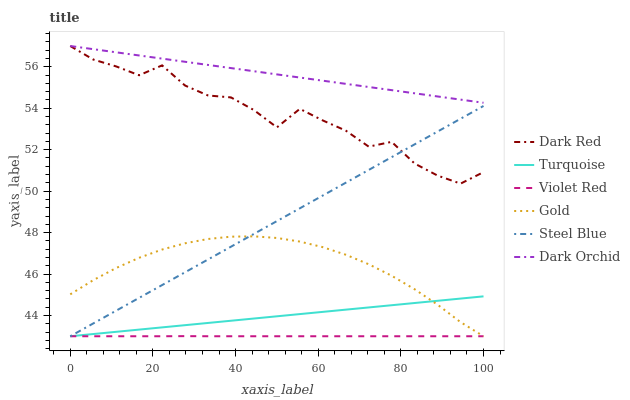Does Violet Red have the minimum area under the curve?
Answer yes or no. Yes. Does Dark Orchid have the maximum area under the curve?
Answer yes or no. Yes. Does Gold have the minimum area under the curve?
Answer yes or no. No. Does Gold have the maximum area under the curve?
Answer yes or no. No. Is Dark Orchid the smoothest?
Answer yes or no. Yes. Is Dark Red the roughest?
Answer yes or no. Yes. Is Gold the smoothest?
Answer yes or no. No. Is Gold the roughest?
Answer yes or no. No. Does Turquoise have the lowest value?
Answer yes or no. Yes. Does Dark Red have the lowest value?
Answer yes or no. No. Does Dark Orchid have the highest value?
Answer yes or no. Yes. Does Gold have the highest value?
Answer yes or no. No. Is Turquoise less than Dark Red?
Answer yes or no. Yes. Is Dark Orchid greater than Violet Red?
Answer yes or no. Yes. Does Steel Blue intersect Gold?
Answer yes or no. Yes. Is Steel Blue less than Gold?
Answer yes or no. No. Is Steel Blue greater than Gold?
Answer yes or no. No. Does Turquoise intersect Dark Red?
Answer yes or no. No. 